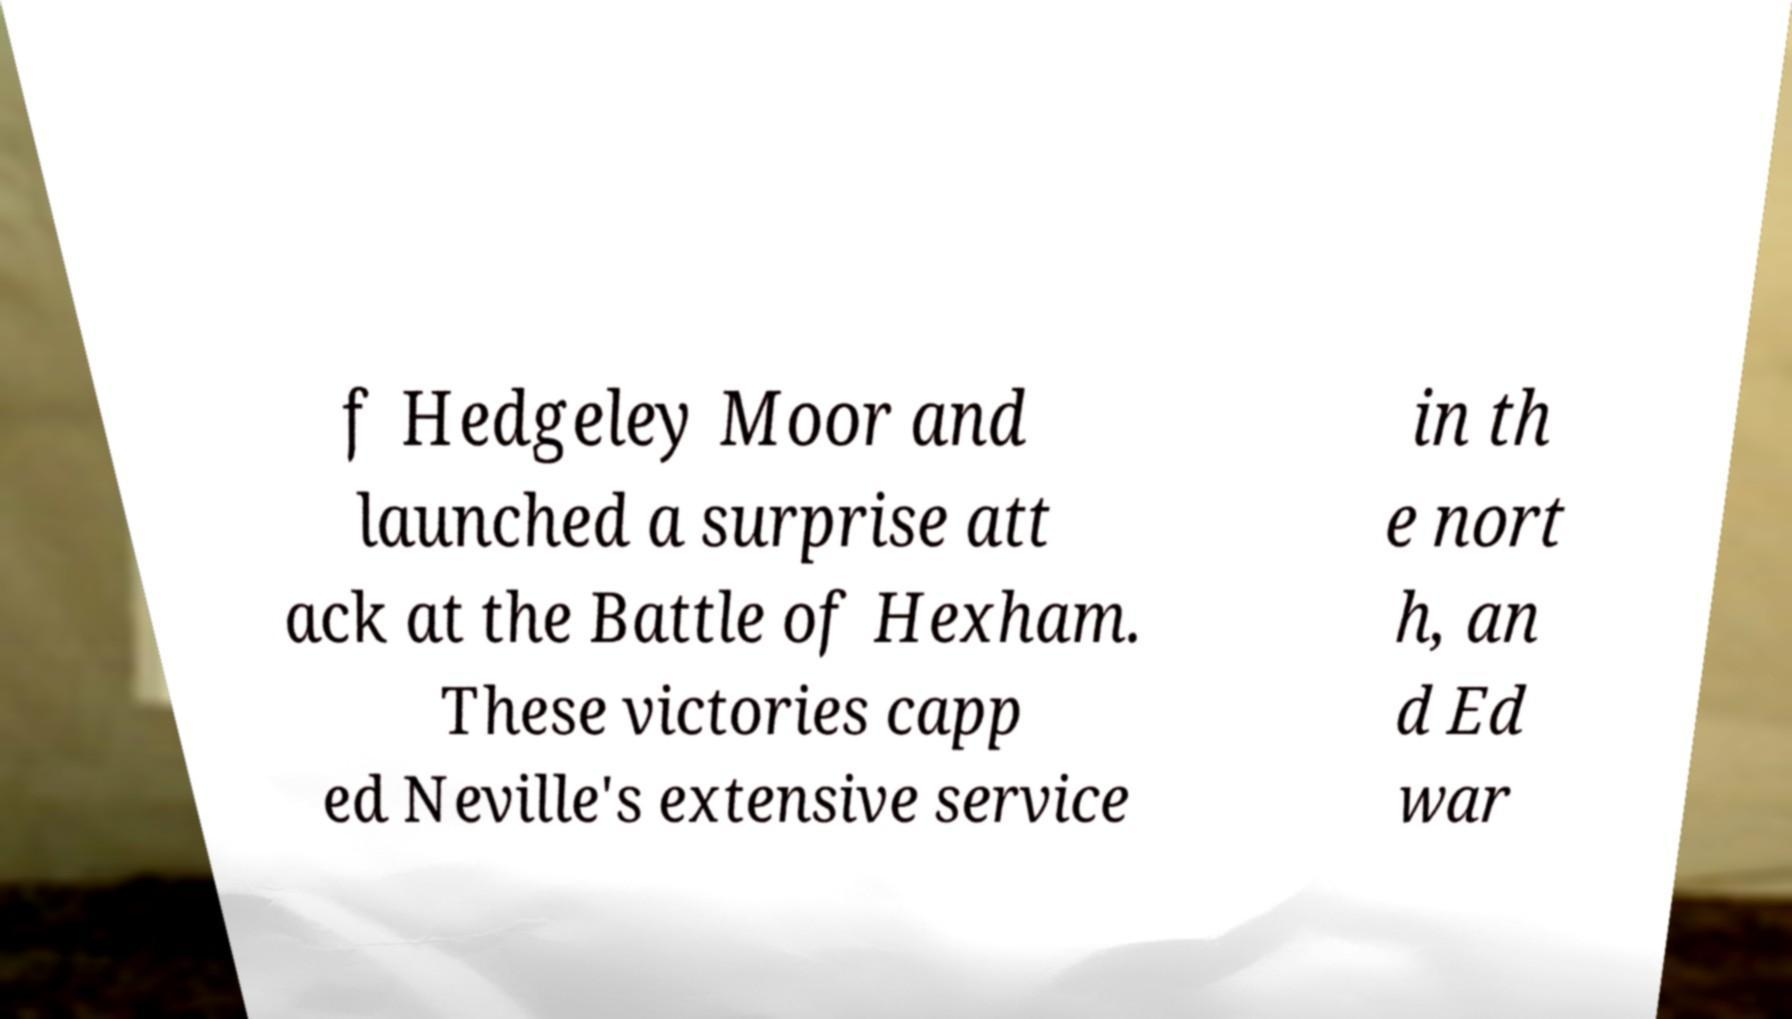For documentation purposes, I need the text within this image transcribed. Could you provide that? f Hedgeley Moor and launched a surprise att ack at the Battle of Hexham. These victories capp ed Neville's extensive service in th e nort h, an d Ed war 